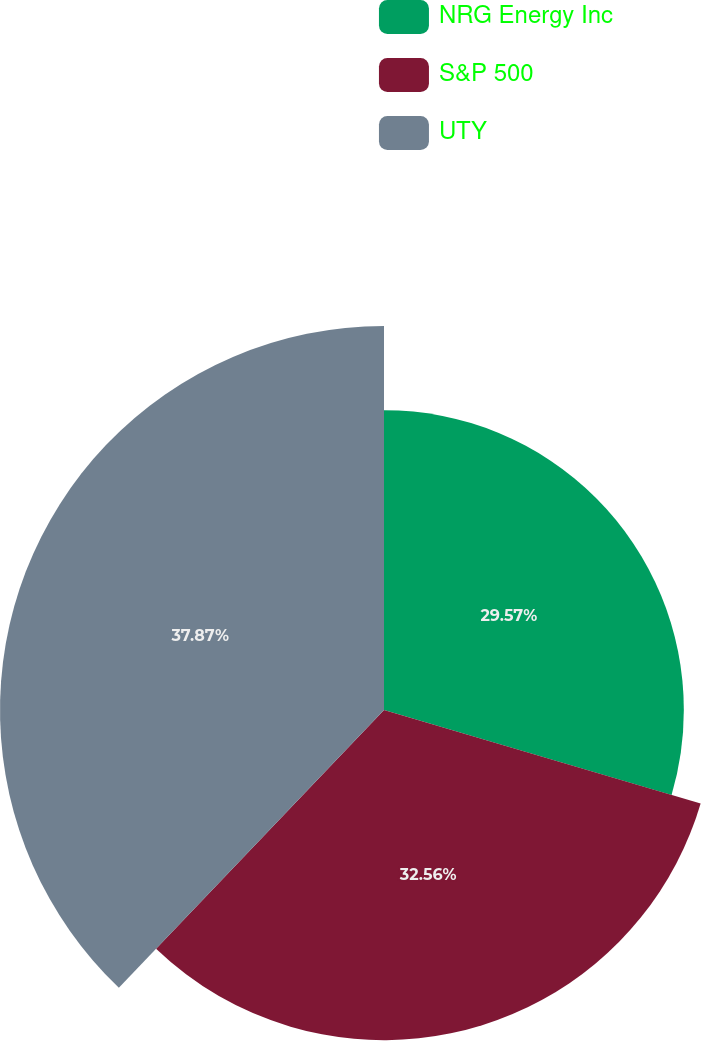Convert chart. <chart><loc_0><loc_0><loc_500><loc_500><pie_chart><fcel>NRG Energy Inc<fcel>S&P 500<fcel>UTY<nl><fcel>29.57%<fcel>32.56%<fcel>37.87%<nl></chart> 